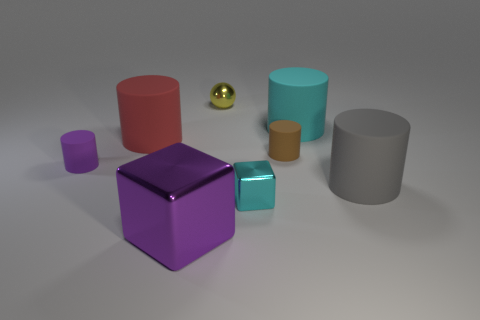Subtract all brown cylinders. How many cylinders are left? 4 Subtract all purple rubber cylinders. How many cylinders are left? 4 Subtract all blue cylinders. Subtract all blue cubes. How many cylinders are left? 5 Add 1 brown matte objects. How many objects exist? 9 Subtract all balls. How many objects are left? 7 Add 7 brown balls. How many brown balls exist? 7 Subtract 0 gray balls. How many objects are left? 8 Subtract all matte cylinders. Subtract all large shiny cubes. How many objects are left? 2 Add 1 cyan cylinders. How many cyan cylinders are left? 2 